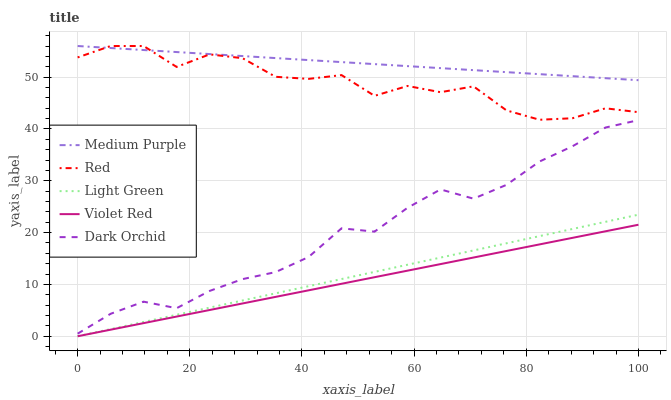Does Violet Red have the minimum area under the curve?
Answer yes or no. Yes. Does Medium Purple have the maximum area under the curve?
Answer yes or no. Yes. Does Dark Orchid have the minimum area under the curve?
Answer yes or no. No. Does Dark Orchid have the maximum area under the curve?
Answer yes or no. No. Is Violet Red the smoothest?
Answer yes or no. Yes. Is Red the roughest?
Answer yes or no. Yes. Is Dark Orchid the smoothest?
Answer yes or no. No. Is Dark Orchid the roughest?
Answer yes or no. No. Does Dark Orchid have the lowest value?
Answer yes or no. No. Does Red have the highest value?
Answer yes or no. Yes. Does Dark Orchid have the highest value?
Answer yes or no. No. Is Violet Red less than Dark Orchid?
Answer yes or no. Yes. Is Red greater than Light Green?
Answer yes or no. Yes. Does Light Green intersect Violet Red?
Answer yes or no. Yes. Is Light Green less than Violet Red?
Answer yes or no. No. Is Light Green greater than Violet Red?
Answer yes or no. No. Does Violet Red intersect Dark Orchid?
Answer yes or no. No. 